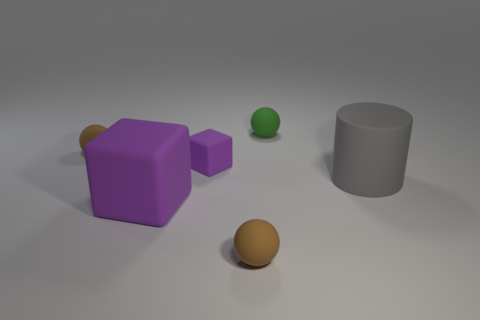Add 2 small green balls. How many objects exist? 8 Subtract all blocks. How many objects are left? 4 Subtract all gray cylinders. Subtract all balls. How many objects are left? 2 Add 3 small purple matte things. How many small purple matte things are left? 4 Add 5 tiny brown cylinders. How many tiny brown cylinders exist? 5 Subtract 0 gray balls. How many objects are left? 6 